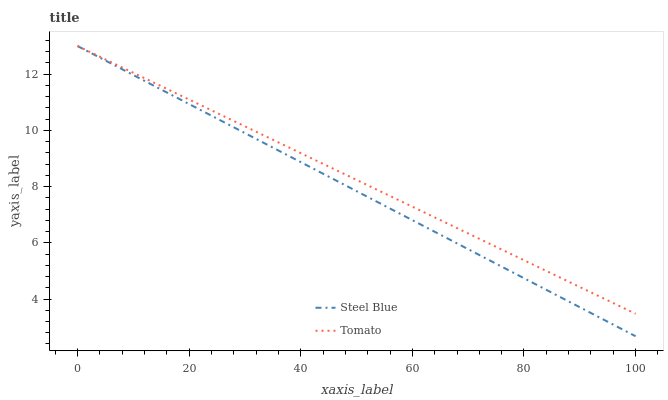Does Steel Blue have the maximum area under the curve?
Answer yes or no. No. Is Steel Blue the roughest?
Answer yes or no. No. 